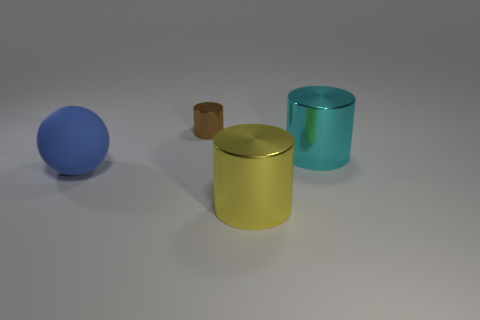Add 2 brown shiny balls. How many objects exist? 6 Subtract all spheres. How many objects are left? 3 Add 1 large cyan metallic spheres. How many large cyan metallic spheres exist? 1 Subtract 0 red cubes. How many objects are left? 4 Subtract all large yellow metallic objects. Subtract all large gray matte objects. How many objects are left? 3 Add 3 cyan objects. How many cyan objects are left? 4 